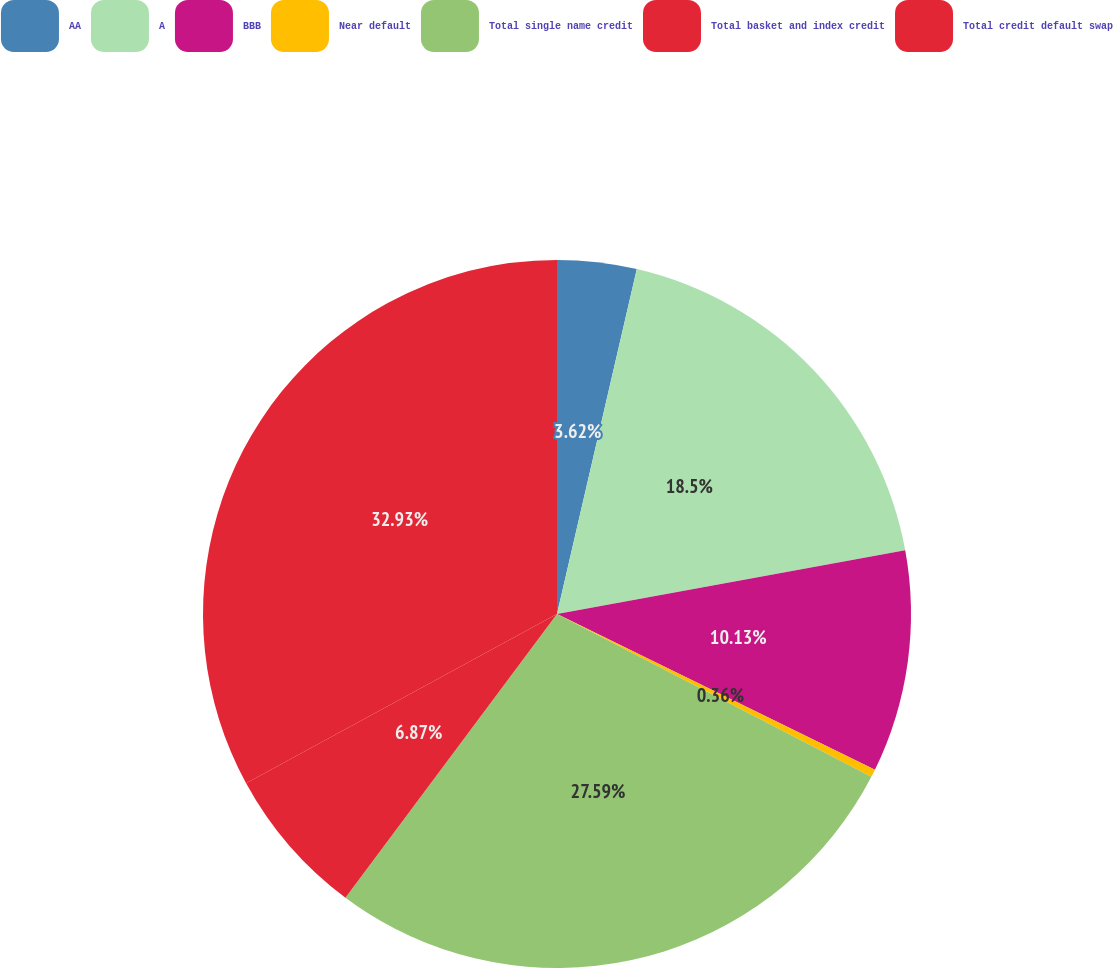Convert chart to OTSL. <chart><loc_0><loc_0><loc_500><loc_500><pie_chart><fcel>AA<fcel>A<fcel>BBB<fcel>Near default<fcel>Total single name credit<fcel>Total basket and index credit<fcel>Total credit default swap<nl><fcel>3.62%<fcel>18.5%<fcel>10.13%<fcel>0.36%<fcel>27.59%<fcel>6.87%<fcel>32.94%<nl></chart> 